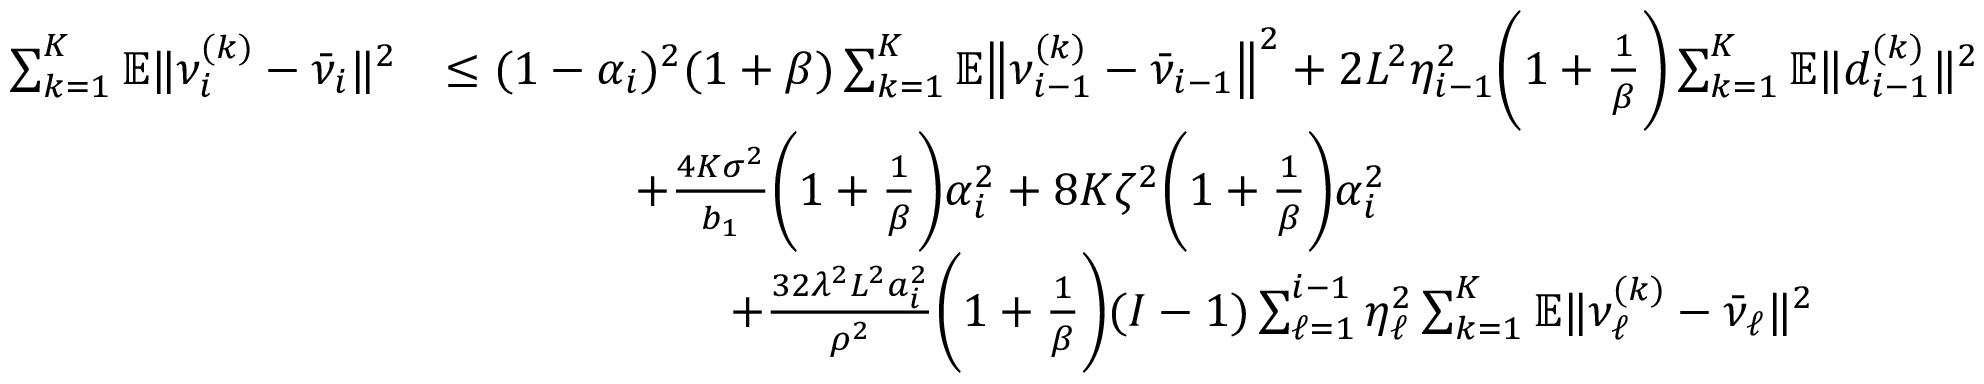<formula> <loc_0><loc_0><loc_500><loc_500>\begin{array} { r l } { \sum _ { k = 1 } ^ { K } \mathbb { E } \| \nu _ { i } ^ { ( k ) } - \bar { \nu } _ { i } \| ^ { 2 } } & { \leq ( 1 - \alpha _ { i } ) ^ { 2 } ( 1 + \beta ) \sum _ { k = 1 } ^ { K } \mathbb { E } \left \| \nu _ { i - 1 } ^ { ( k ) } - \bar { \nu } _ { i - 1 } \right \| ^ { 2 } + 2 L ^ { 2 } \eta _ { i - 1 } ^ { 2 } \left ( 1 + \frac { 1 } { \beta } \right ) \sum _ { k = 1 } ^ { K } \mathbb { E } \| d _ { i - 1 } ^ { ( k ) } \| ^ { 2 } } \\ & { \quad + \frac { 4 K \sigma ^ { 2 } } { b _ { 1 } } \left ( 1 + \frac { 1 } { \beta } \right ) \alpha _ { i } ^ { 2 } + 8 K \zeta ^ { 2 } \left ( 1 + \frac { 1 } { \beta } \right ) \alpha _ { i } ^ { 2 } } \\ & { \quad + \frac { 3 2 \lambda ^ { 2 } L ^ { 2 } a _ { i } ^ { 2 } } { \rho ^ { 2 } } \left ( 1 + \frac { 1 } { \beta } \right ) { ( I - 1 ) } \sum _ { \ell = 1 } ^ { i - 1 } \eta _ { \ell } ^ { 2 } \sum _ { k = 1 } ^ { K } \mathbb { E } \| \nu _ { \ell } ^ { ( k ) } - \bar { \nu } _ { \ell } \| ^ { 2 } } \end{array}</formula> 